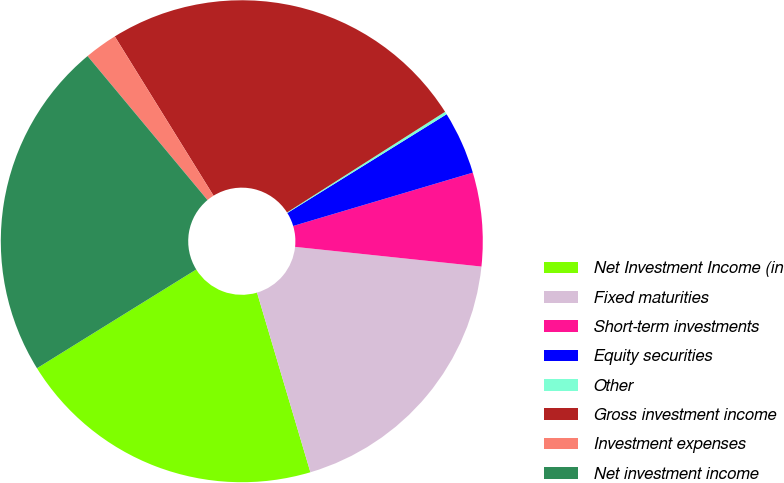Convert chart. <chart><loc_0><loc_0><loc_500><loc_500><pie_chart><fcel>Net Investment Income (in<fcel>Fixed maturities<fcel>Short-term investments<fcel>Equity securities<fcel>Other<fcel>Gross investment income<fcel>Investment expenses<fcel>Net investment income<nl><fcel>20.76%<fcel>18.73%<fcel>6.27%<fcel>4.24%<fcel>0.19%<fcel>24.81%<fcel>2.22%<fcel>22.78%<nl></chart> 